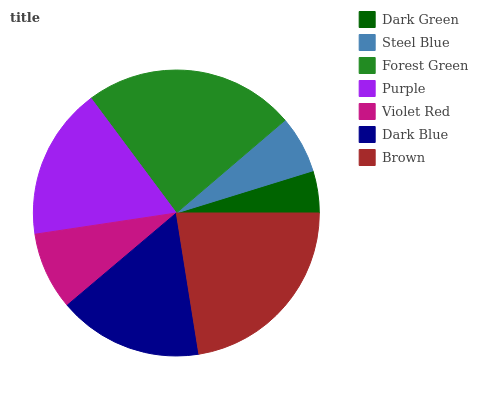Is Dark Green the minimum?
Answer yes or no. Yes. Is Forest Green the maximum?
Answer yes or no. Yes. Is Steel Blue the minimum?
Answer yes or no. No. Is Steel Blue the maximum?
Answer yes or no. No. Is Steel Blue greater than Dark Green?
Answer yes or no. Yes. Is Dark Green less than Steel Blue?
Answer yes or no. Yes. Is Dark Green greater than Steel Blue?
Answer yes or no. No. Is Steel Blue less than Dark Green?
Answer yes or no. No. Is Dark Blue the high median?
Answer yes or no. Yes. Is Dark Blue the low median?
Answer yes or no. Yes. Is Violet Red the high median?
Answer yes or no. No. Is Brown the low median?
Answer yes or no. No. 